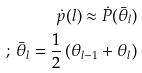<formula> <loc_0><loc_0><loc_500><loc_500>\dot { p } ( l ) \approx \dot { P } ( \bar { \theta } _ { l } ) \\ ; \, \bar { \theta } _ { l } = \frac { 1 } { 2 } \left ( \theta _ { l - 1 } + \theta _ { l } \right )</formula> 